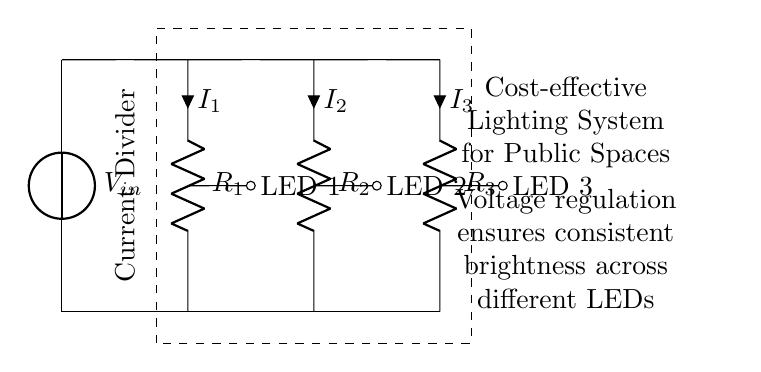What is the total number of resistors in the circuit? The circuit diagram shows three resistors labeled as R1, R2, and R3, which are connected to the voltage source and to the LEDs.
Answer: 3 What is the purpose of the voltage source? The voltage source labeled as V_in provides the energy required to drive the currents through the resistors and LEDs in the circuit.
Answer: Energy source What do the arrows next to the resistors represent? The arrows next to the resistors labeled I1, I2, and I3 indicate the direction of current flow through each resistor.
Answer: Current flow Which components are connected in parallel in this circuit? The resistors R1, R2, and R3 are connected in parallel because they share the same voltage input from the V_in source but allow current to divide through them.
Answer: R1, R2, R3 How does the current division affect the brightness of the LEDs? Since each LED is connected across a resistor, the total current from the source divides among the parallel resistors; thus, the voltage across each LED remains constant, regulating their brightness uniformly despite the division.
Answer: Consistent brightness What is the role of voltage regulation in this circuit? Voltage regulation ensures that each LED receives a specific and stable voltage to maintain operating conditions despite variations in total current or loads, providing consistent performance in public lighting.
Answer: Stability What type of circuit is represented here? This circuit is specifically a Current Divider, which divides the input current among multiple outputs (in this case, the LEDs) based on the resistance values.
Answer: Current Divider 